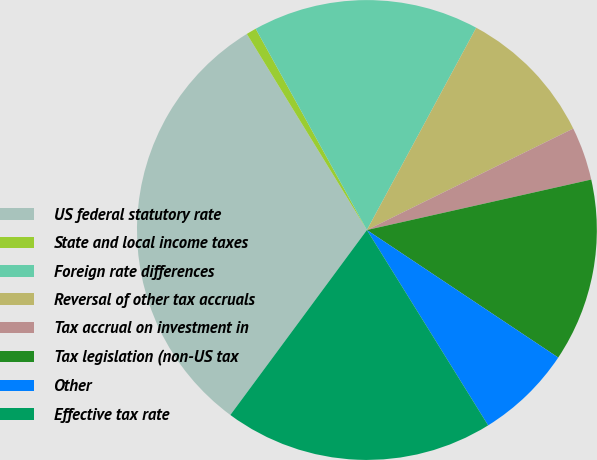<chart> <loc_0><loc_0><loc_500><loc_500><pie_chart><fcel>US federal statutory rate<fcel>State and local income taxes<fcel>Foreign rate differences<fcel>Reversal of other tax accruals<fcel>Tax accrual on investment in<fcel>Tax legislation (non-US tax<fcel>Other<fcel>Effective tax rate<nl><fcel>31.13%<fcel>0.71%<fcel>15.92%<fcel>9.84%<fcel>3.75%<fcel>12.88%<fcel>6.8%<fcel>18.96%<nl></chart> 